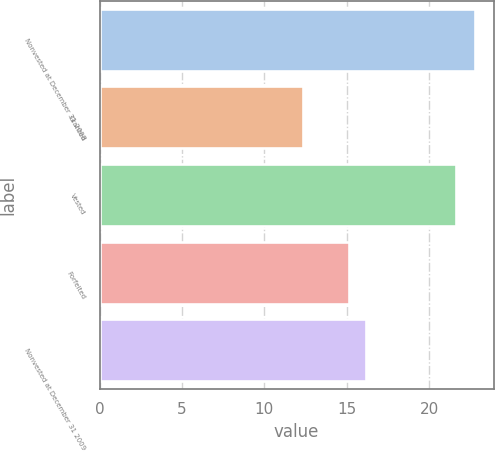Convert chart to OTSL. <chart><loc_0><loc_0><loc_500><loc_500><bar_chart><fcel>Nonvested at December 31 2008<fcel>Granted<fcel>Vested<fcel>Forfeited<fcel>Nonvested at December 31 2009<nl><fcel>22.77<fcel>12.32<fcel>21.62<fcel>15.14<fcel>16.19<nl></chart> 